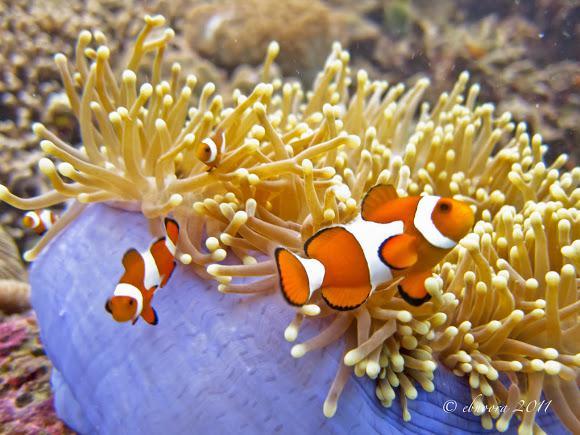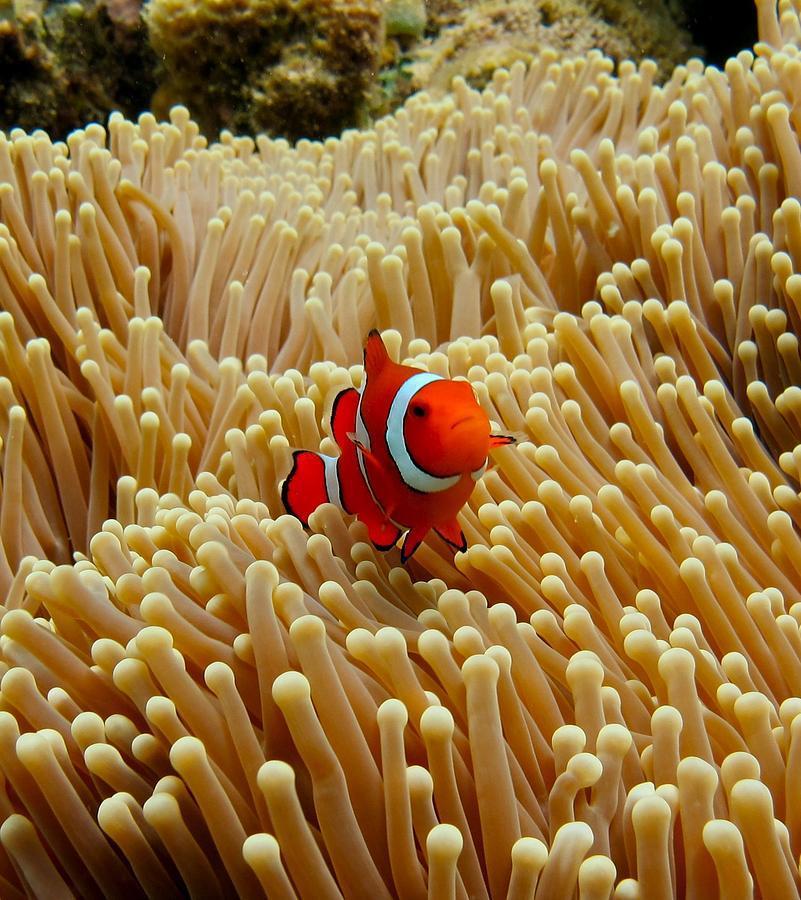The first image is the image on the left, the second image is the image on the right. Examine the images to the left and right. Is the description "In at least one image there is a single clownfish swimming right forward through arms of corral." accurate? Answer yes or no. Yes. The first image is the image on the left, the second image is the image on the right. For the images shown, is this caption "One image shows exactly one clownfish, which is angled facing rightward above pale anemone tendrils, and the other image includes two clownfish with three stripes each visible in the foreground swimming by pale anemone tendrils." true? Answer yes or no. Yes. 